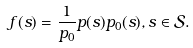<formula> <loc_0><loc_0><loc_500><loc_500>f ( s ) = \frac { 1 } { p _ { 0 } } p ( s ) p _ { 0 } ( s ) , s \in \mathcal { S } .</formula> 